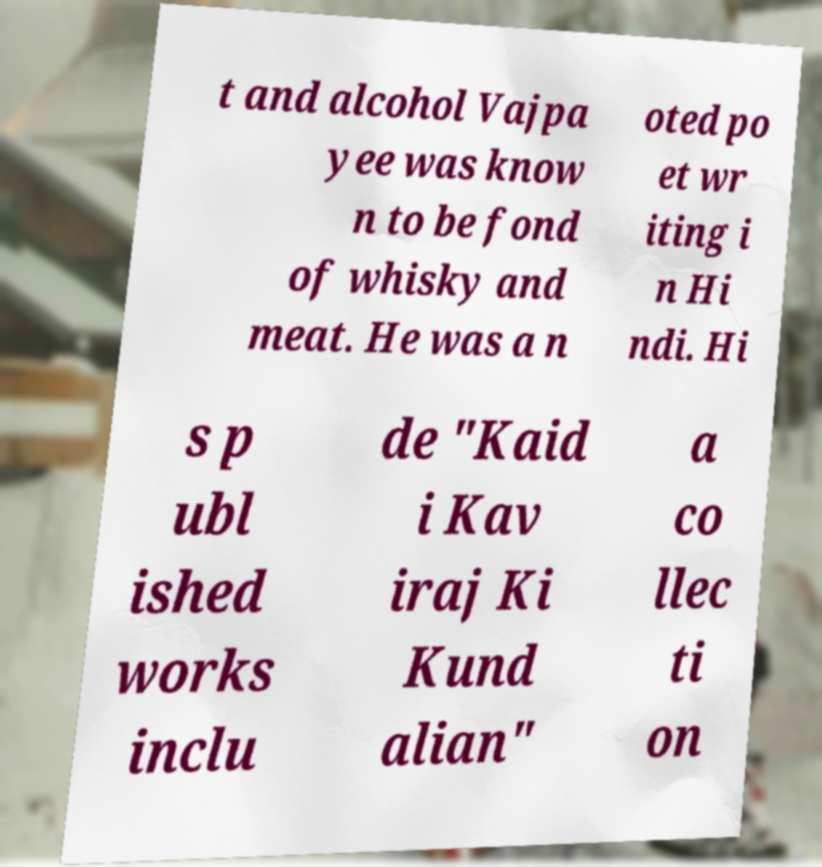Could you extract and type out the text from this image? t and alcohol Vajpa yee was know n to be fond of whisky and meat. He was a n oted po et wr iting i n Hi ndi. Hi s p ubl ished works inclu de "Kaid i Kav iraj Ki Kund alian" a co llec ti on 